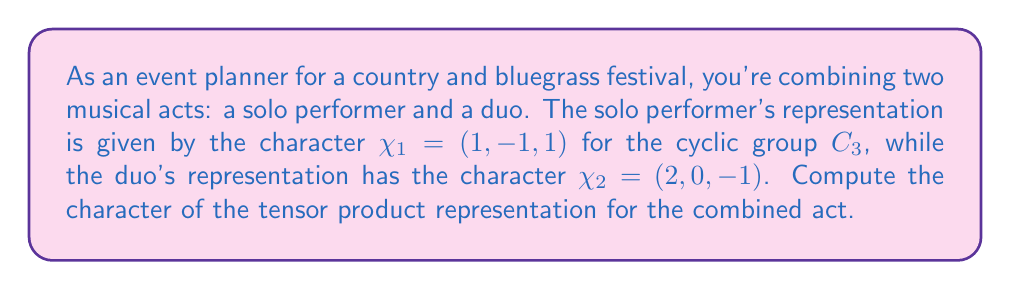Can you solve this math problem? To solve this problem, we'll follow these steps:

1) Recall that for two representations $V$ and $W$ of a group $G$ with characters $\chi_V$ and $\chi_W$, the character of their tensor product $V \otimes W$ is given by the pointwise product of their characters:

   $\chi_{V \otimes W}(g) = \chi_V(g) \cdot \chi_W(g)$ for all $g \in G$

2) In this case, we have:
   $\chi_1 = (1, -1, 1)$ for the solo performer
   $\chi_2 = (2, 0, -1)$ for the duo

3) Let's call the character of the tensor product $\chi_3$. We'll compute it element-wise:

   For the first element:
   $\chi_3(e) = \chi_1(e) \cdot \chi_2(e) = 1 \cdot 2 = 2$

   For the second element:
   $\chi_3(g) = \chi_1(g) \cdot \chi_2(g) = (-1) \cdot 0 = 0$

   For the third element:
   $\chi_3(g^2) = \chi_1(g^2) \cdot \chi_2(g^2) = 1 \cdot (-1) = -1$

4) Therefore, the character of the tensor product representation is:

   $\chi_3 = (2, 0, -1)$

This represents the combined act of the solo performer and the duo in terms of their group representations.
Answer: $(2, 0, -1)$ 